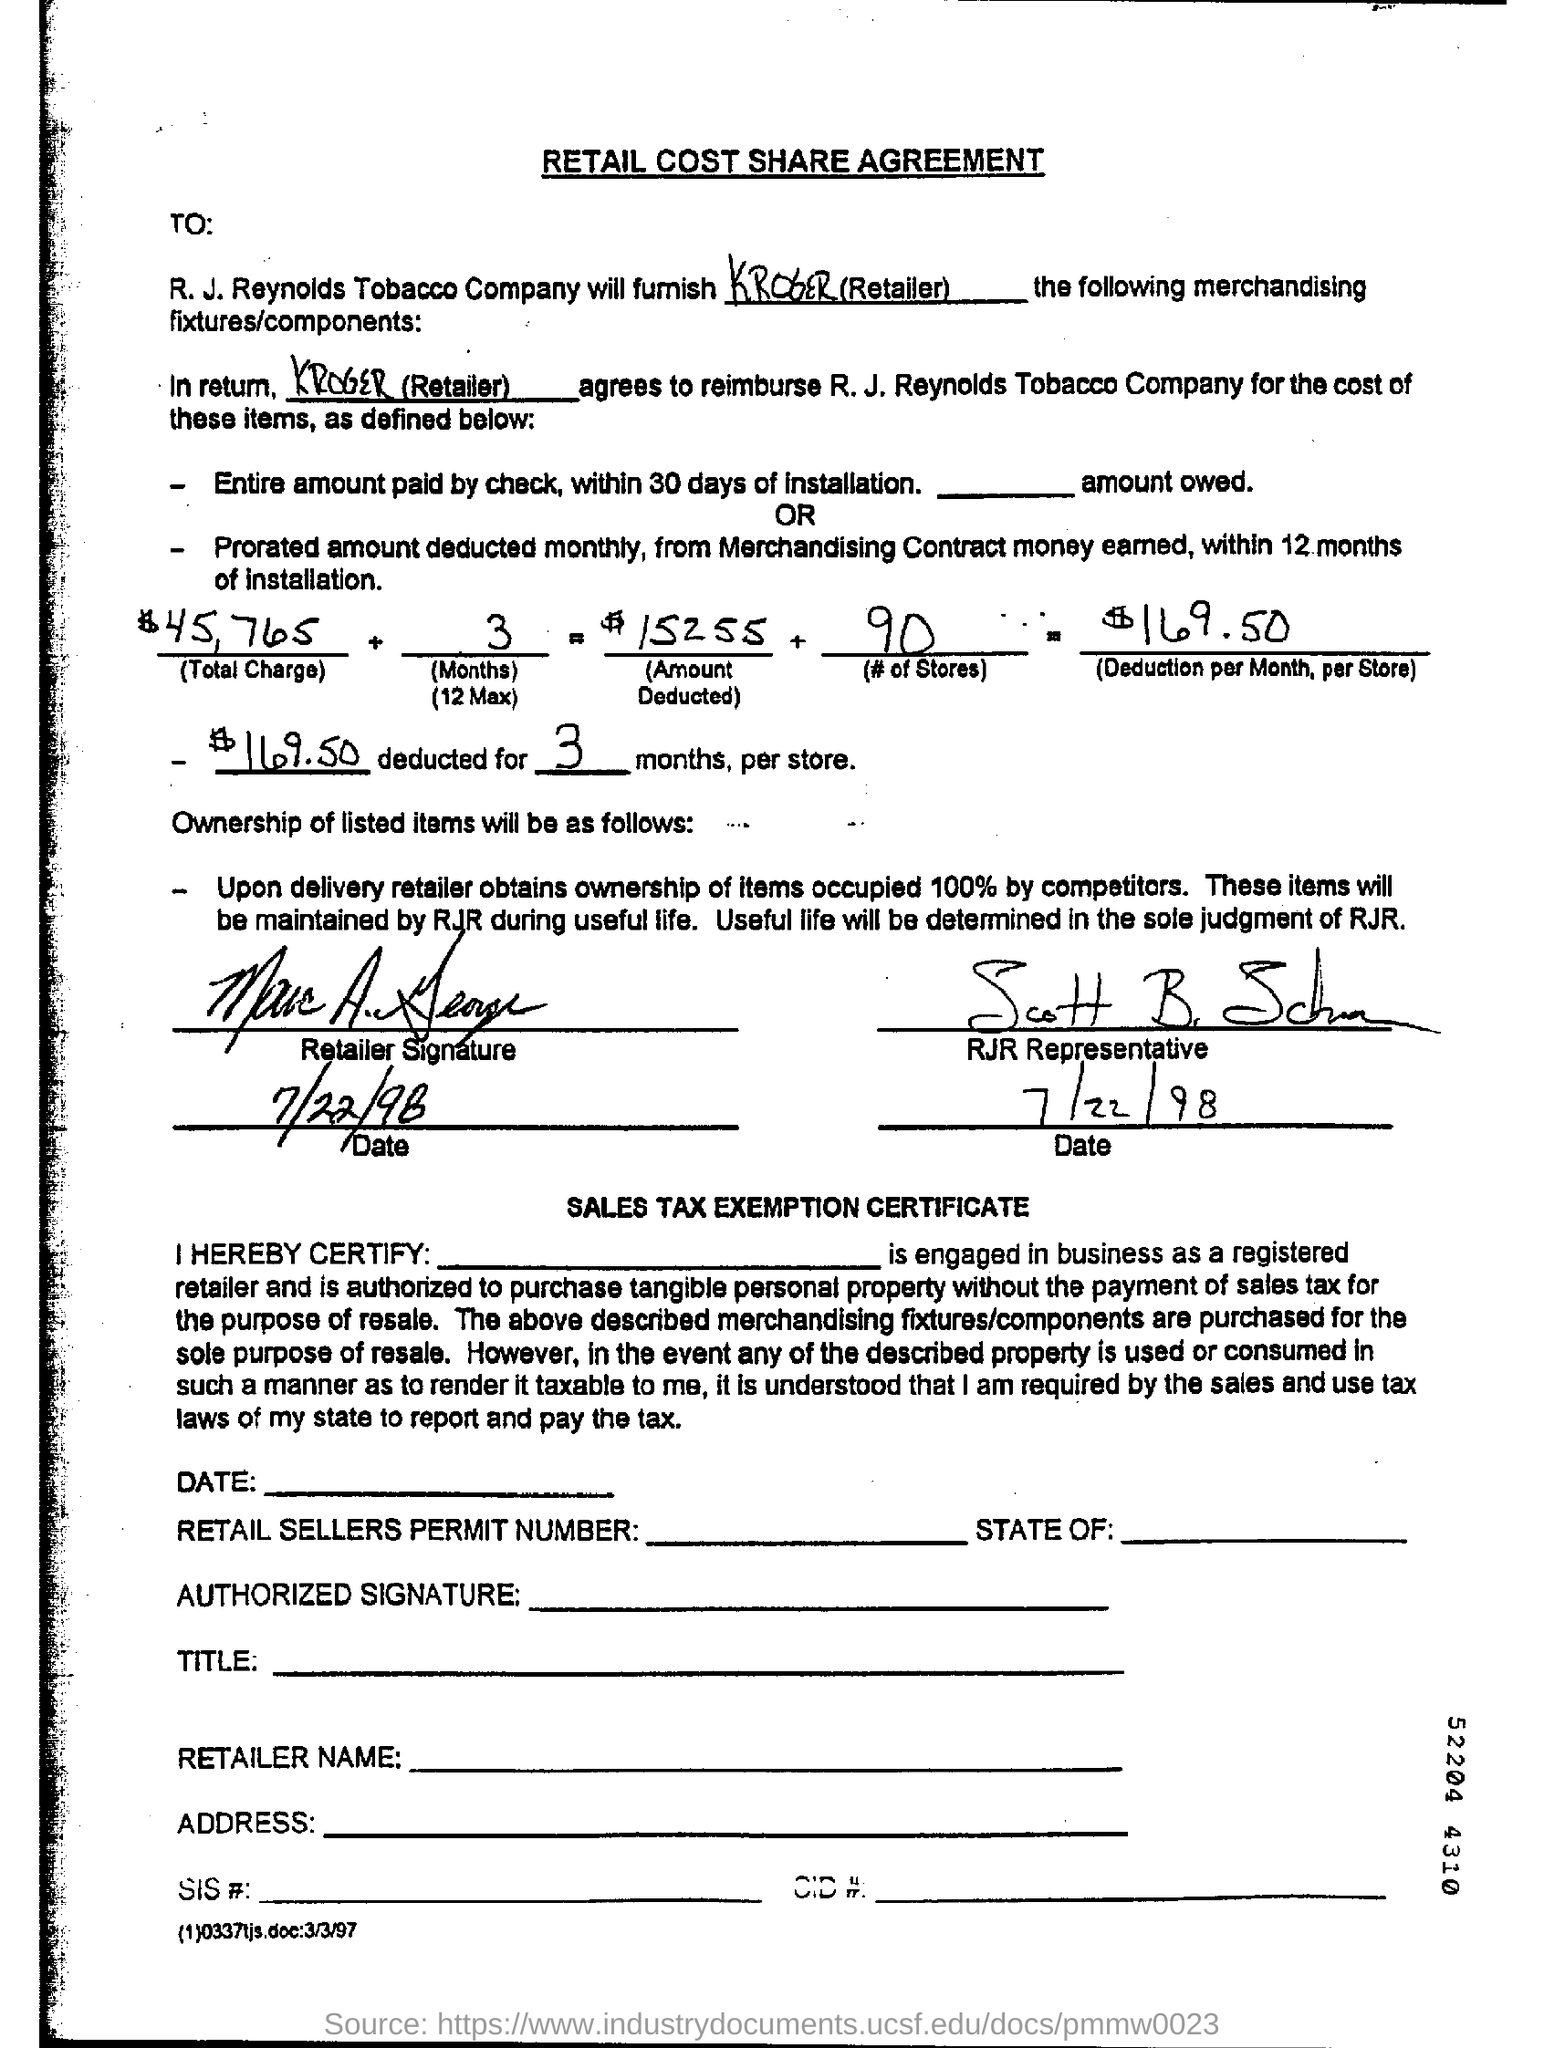What is the heading at top of the page ?
Your response must be concise. Retail Cost Share Agreement. How much is the deduction per month, per store ?
Offer a very short reply. $169.50. Who is the retailer ?
Offer a very short reply. Kroger. What is the # of stores?
Offer a very short reply. 90. 